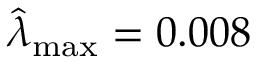<formula> <loc_0><loc_0><loc_500><loc_500>\widehat { \lambda } _ { \max } = 0 . 0 0 8</formula> 